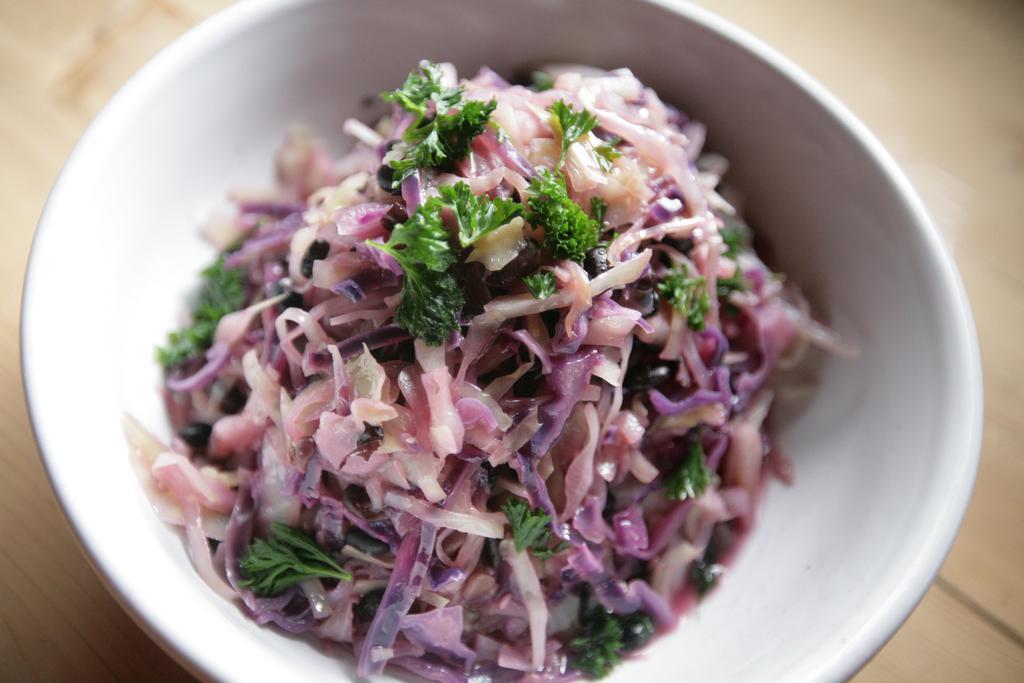In one or two sentences, can you explain what this image depicts? In this image there is some food item kept in a white color bowl as we can see in middle of this image and there is a floor in the background. 